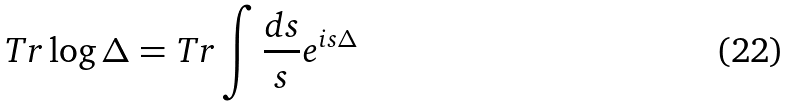Convert formula to latex. <formula><loc_0><loc_0><loc_500><loc_500>T r \log \Delta = T r \int \frac { d s } { s } e ^ { i s \Delta }</formula> 